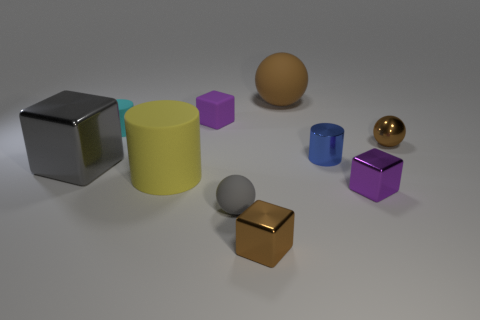Subtract all red blocks. Subtract all brown balls. How many blocks are left? 4 Subtract all cubes. How many objects are left? 6 Subtract 1 gray spheres. How many objects are left? 9 Subtract all large brown metallic cubes. Subtract all big gray objects. How many objects are left? 9 Add 3 small blue metal objects. How many small blue metal objects are left? 4 Add 9 small gray rubber objects. How many small gray rubber objects exist? 10 